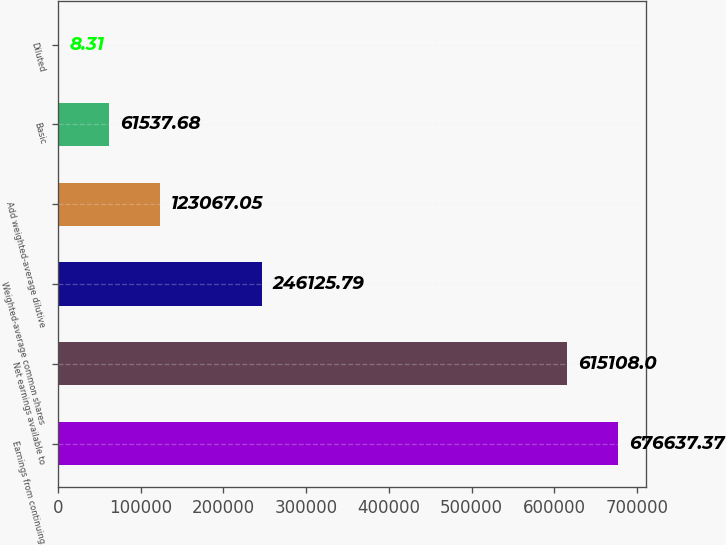Convert chart. <chart><loc_0><loc_0><loc_500><loc_500><bar_chart><fcel>Earnings from continuing<fcel>Net earnings available to<fcel>Weighted-average common shares<fcel>Add weighted-average dilutive<fcel>Basic<fcel>Diluted<nl><fcel>676637<fcel>615108<fcel>246126<fcel>123067<fcel>61537.7<fcel>8.31<nl></chart> 